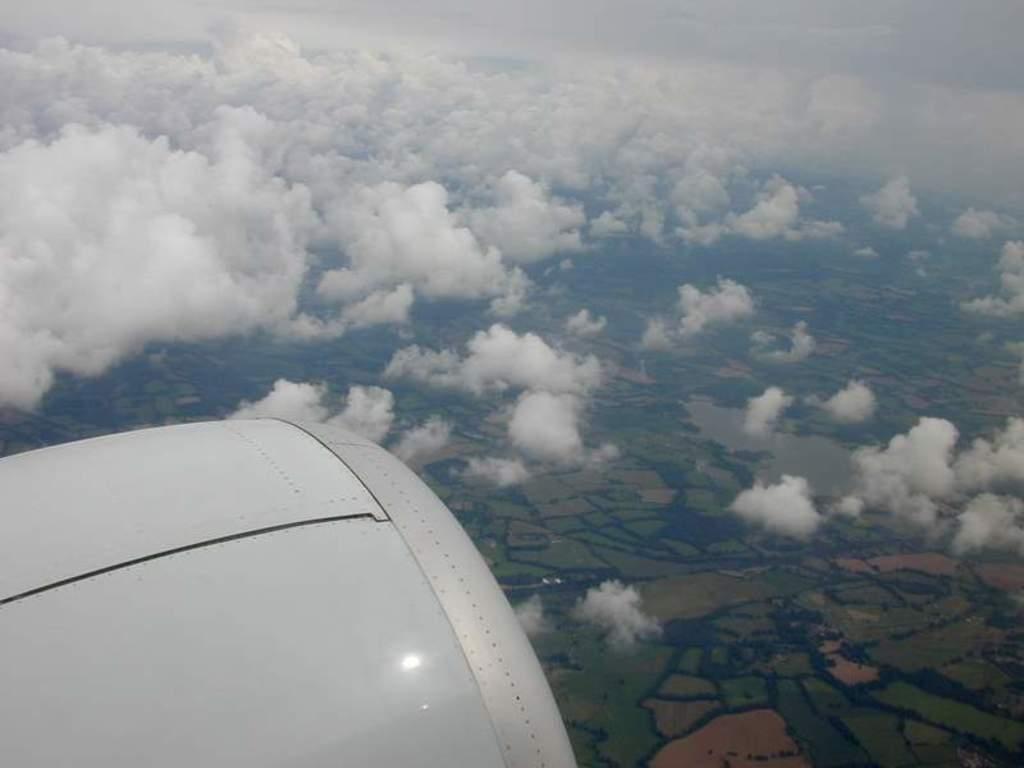Describe this image in one or two sentences. In this picture we can see clouded sky, down we can see grass. 